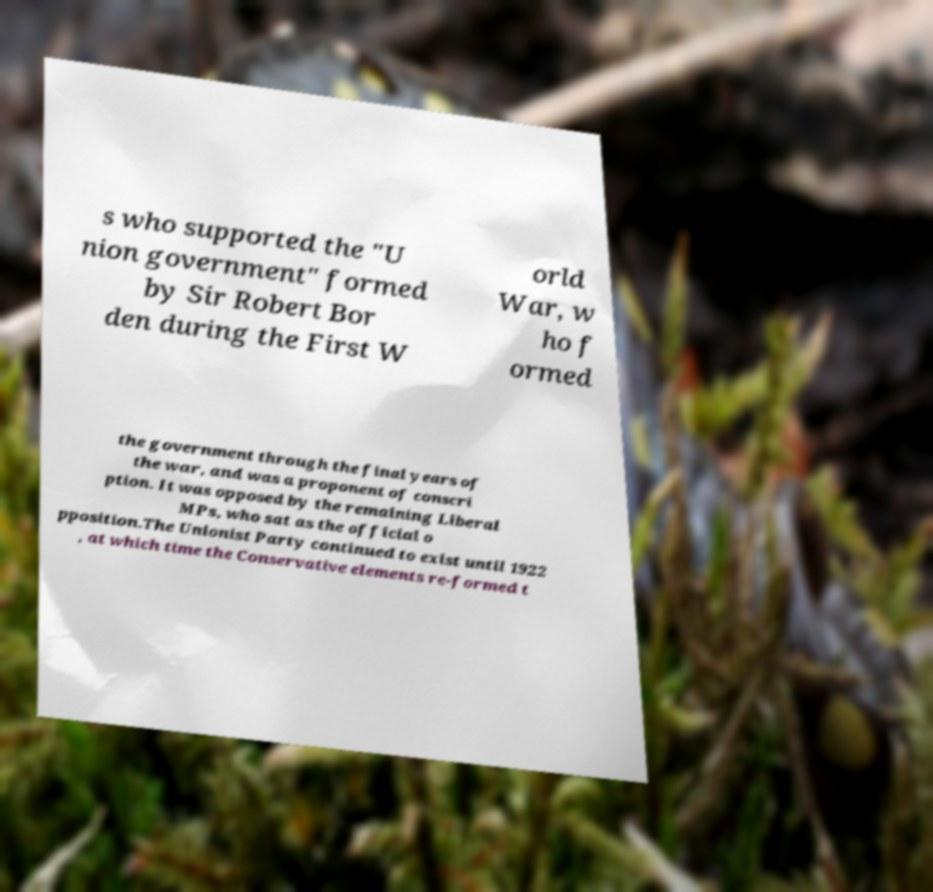Can you read and provide the text displayed in the image?This photo seems to have some interesting text. Can you extract and type it out for me? s who supported the "U nion government" formed by Sir Robert Bor den during the First W orld War, w ho f ormed the government through the final years of the war, and was a proponent of conscri ption. It was opposed by the remaining Liberal MPs, who sat as the official o pposition.The Unionist Party continued to exist until 1922 , at which time the Conservative elements re-formed t 